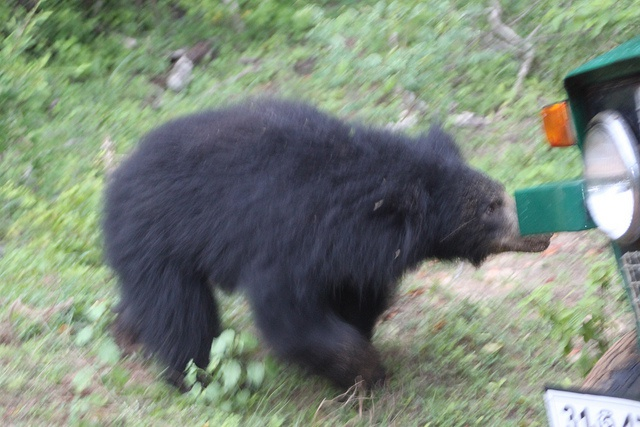Describe the objects in this image and their specific colors. I can see bear in green, gray, and black tones and truck in green, lavender, black, darkgray, and gray tones in this image. 